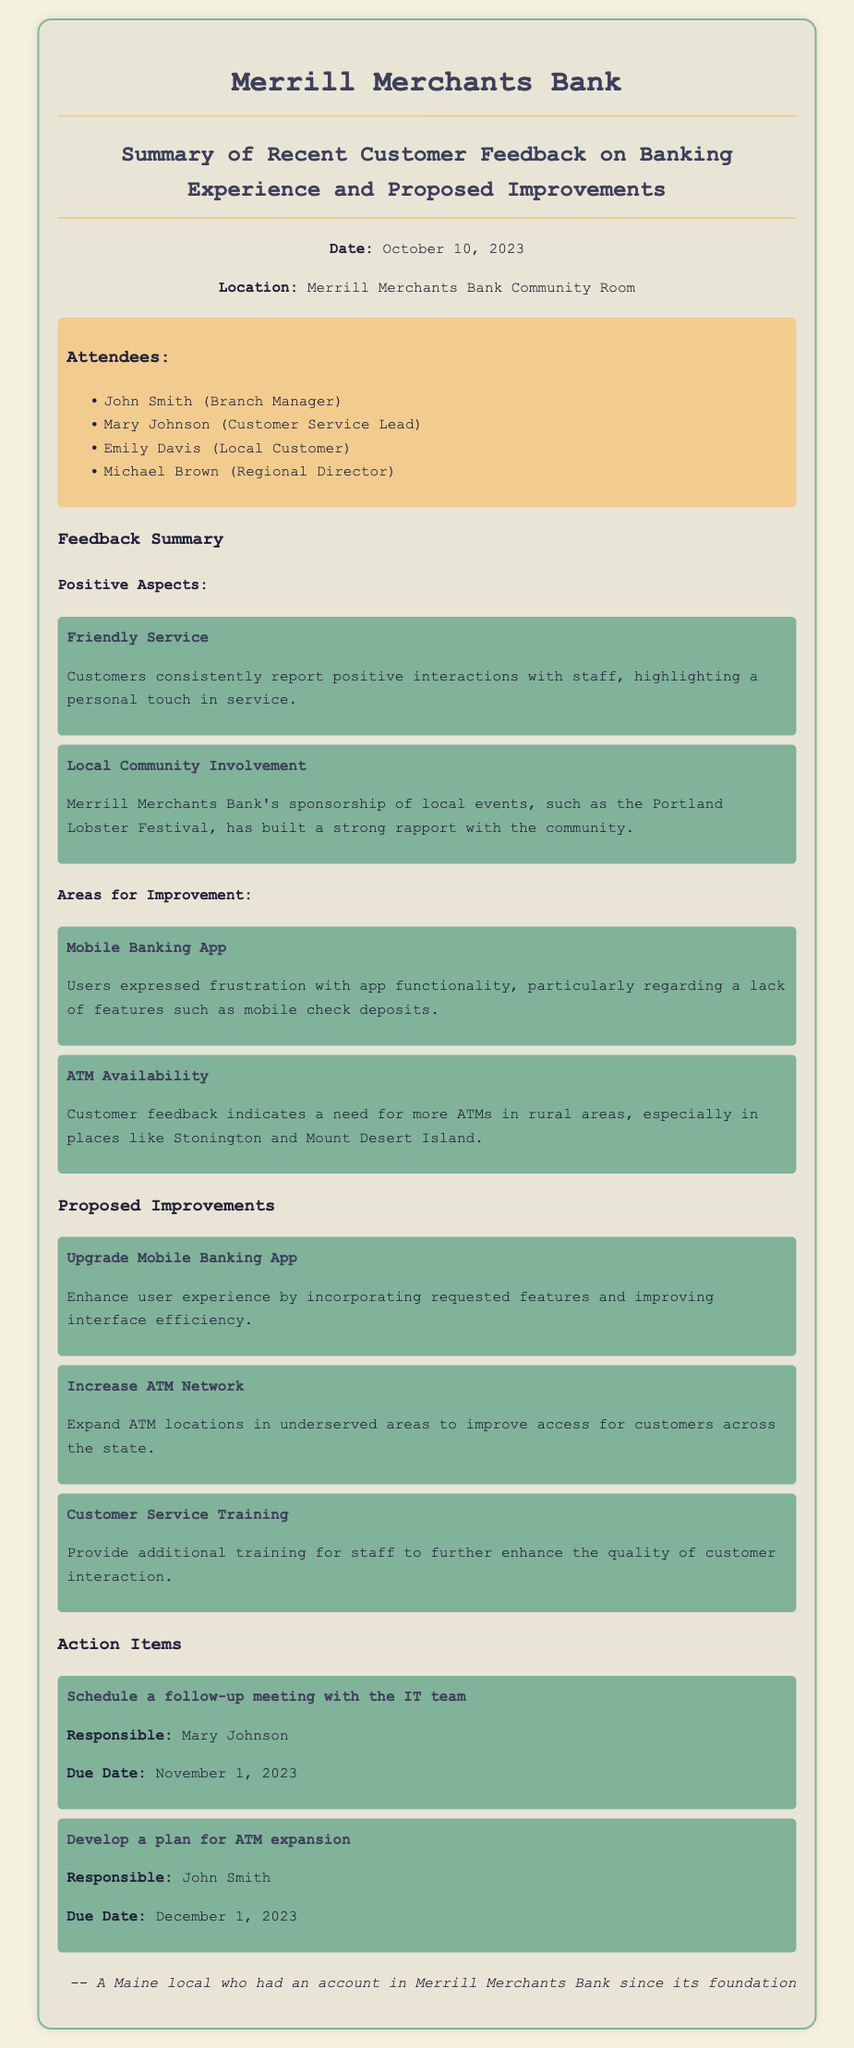What is the date of the meeting? The date of the meeting is mentioned at the beginning of the document.
Answer: October 10, 2023 Who is responsible for scheduling a follow-up meeting with the IT team? The document specifies who is responsible for each action item, including this one.
Answer: Mary Johnson What improvement is proposed for the mobile banking app? The proposed improvements for the mobile banking app are detailed in the improvements section.
Answer: Upgrade Mobile Banking App Which local event has the bank sponsored? The document mentions a specific local event that the bank has sponsored as part of its community involvement.
Answer: Portland Lobster Festival How many attendees are listed in the document? The number of attendees can be counted directly from the list provided in the document.
Answer: Four What area was highlighted as needing more ATMs? Specific areas where ATMs are needed are mentioned under the feedback summary.
Answer: Stonington and Mount Desert Island What is the due date for the ATM expansion plan? The due date for the action item related to ATM expansion is clearly stated in the action items section.
Answer: December 1, 2023 